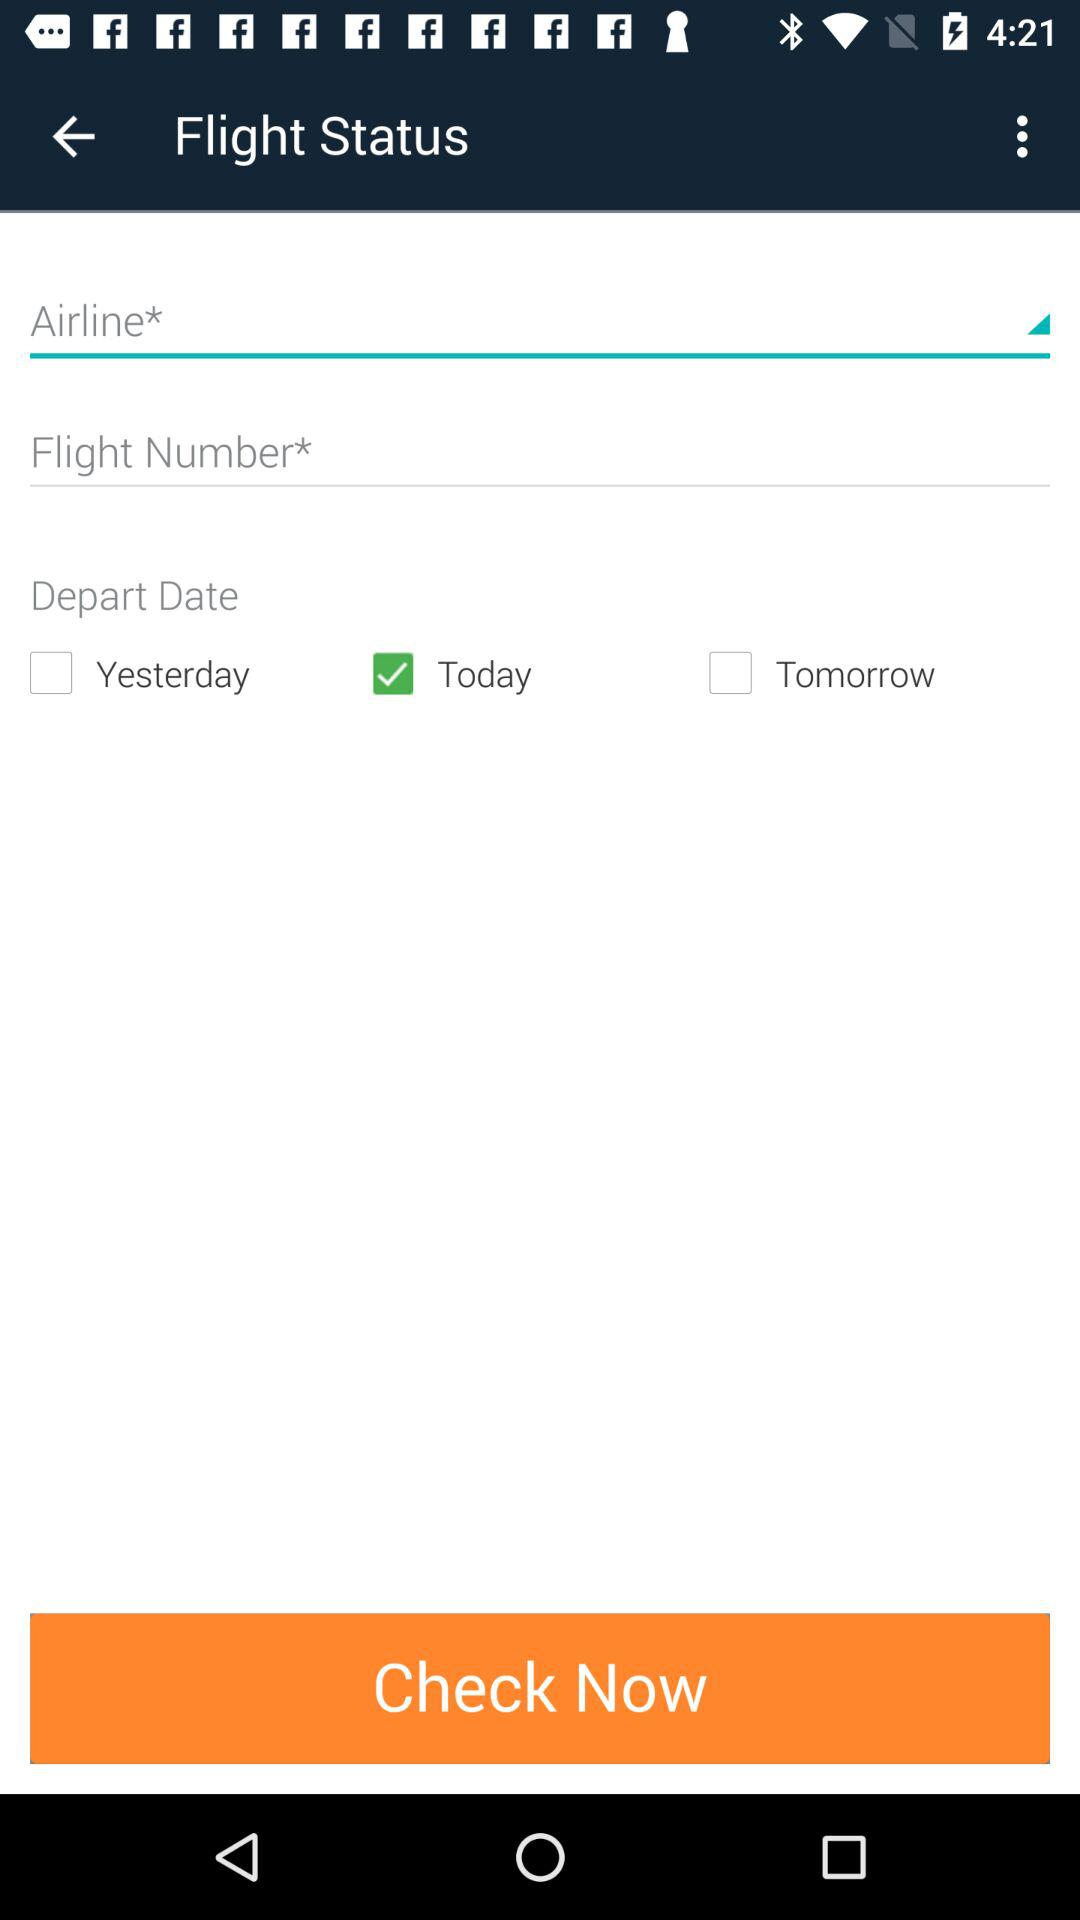How many checkboxes are there that are not selected?
Answer the question using a single word or phrase. 2 